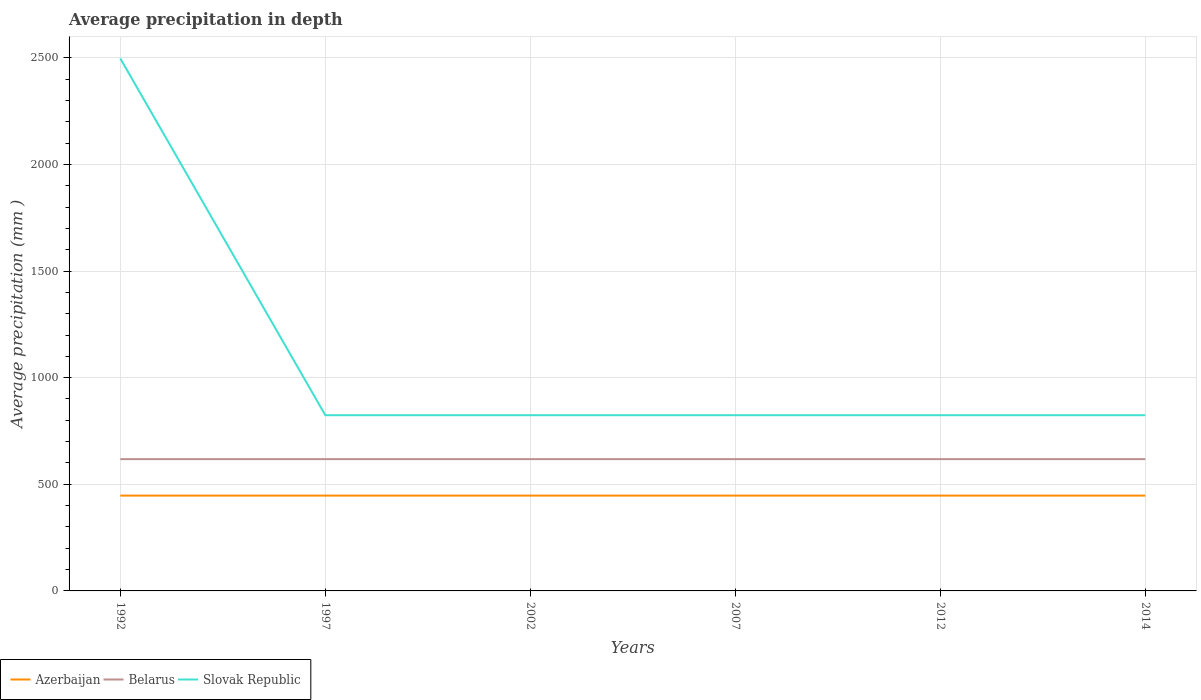Does the line corresponding to Azerbaijan intersect with the line corresponding to Slovak Republic?
Keep it short and to the point. No. Is the number of lines equal to the number of legend labels?
Your answer should be very brief. Yes. Across all years, what is the maximum average precipitation in Azerbaijan?
Ensure brevity in your answer.  447. What is the difference between the highest and the lowest average precipitation in Slovak Republic?
Provide a succinct answer. 1. Is the average precipitation in Slovak Republic strictly greater than the average precipitation in Azerbaijan over the years?
Your response must be concise. No. How many years are there in the graph?
Make the answer very short. 6. Are the values on the major ticks of Y-axis written in scientific E-notation?
Ensure brevity in your answer.  No. What is the title of the graph?
Your response must be concise. Average precipitation in depth. What is the label or title of the Y-axis?
Provide a succinct answer. Average precipitation (mm ). What is the Average precipitation (mm ) in Azerbaijan in 1992?
Make the answer very short. 447. What is the Average precipitation (mm ) in Belarus in 1992?
Ensure brevity in your answer.  618. What is the Average precipitation (mm ) in Slovak Republic in 1992?
Make the answer very short. 2497. What is the Average precipitation (mm ) of Azerbaijan in 1997?
Your answer should be compact. 447. What is the Average precipitation (mm ) of Belarus in 1997?
Ensure brevity in your answer.  618. What is the Average precipitation (mm ) in Slovak Republic in 1997?
Offer a terse response. 824. What is the Average precipitation (mm ) in Azerbaijan in 2002?
Provide a short and direct response. 447. What is the Average precipitation (mm ) in Belarus in 2002?
Offer a very short reply. 618. What is the Average precipitation (mm ) of Slovak Republic in 2002?
Provide a succinct answer. 824. What is the Average precipitation (mm ) of Azerbaijan in 2007?
Provide a short and direct response. 447. What is the Average precipitation (mm ) of Belarus in 2007?
Your answer should be very brief. 618. What is the Average precipitation (mm ) in Slovak Republic in 2007?
Your answer should be very brief. 824. What is the Average precipitation (mm ) in Azerbaijan in 2012?
Make the answer very short. 447. What is the Average precipitation (mm ) of Belarus in 2012?
Ensure brevity in your answer.  618. What is the Average precipitation (mm ) in Slovak Republic in 2012?
Your response must be concise. 824. What is the Average precipitation (mm ) in Azerbaijan in 2014?
Give a very brief answer. 447. What is the Average precipitation (mm ) of Belarus in 2014?
Make the answer very short. 618. What is the Average precipitation (mm ) of Slovak Republic in 2014?
Offer a very short reply. 824. Across all years, what is the maximum Average precipitation (mm ) of Azerbaijan?
Provide a short and direct response. 447. Across all years, what is the maximum Average precipitation (mm ) of Belarus?
Give a very brief answer. 618. Across all years, what is the maximum Average precipitation (mm ) of Slovak Republic?
Your response must be concise. 2497. Across all years, what is the minimum Average precipitation (mm ) in Azerbaijan?
Your answer should be compact. 447. Across all years, what is the minimum Average precipitation (mm ) in Belarus?
Your answer should be compact. 618. Across all years, what is the minimum Average precipitation (mm ) of Slovak Republic?
Your answer should be very brief. 824. What is the total Average precipitation (mm ) of Azerbaijan in the graph?
Make the answer very short. 2682. What is the total Average precipitation (mm ) in Belarus in the graph?
Your answer should be very brief. 3708. What is the total Average precipitation (mm ) of Slovak Republic in the graph?
Keep it short and to the point. 6617. What is the difference between the Average precipitation (mm ) of Azerbaijan in 1992 and that in 1997?
Give a very brief answer. 0. What is the difference between the Average precipitation (mm ) of Slovak Republic in 1992 and that in 1997?
Offer a very short reply. 1673. What is the difference between the Average precipitation (mm ) in Azerbaijan in 1992 and that in 2002?
Offer a terse response. 0. What is the difference between the Average precipitation (mm ) in Slovak Republic in 1992 and that in 2002?
Your answer should be very brief. 1673. What is the difference between the Average precipitation (mm ) of Azerbaijan in 1992 and that in 2007?
Offer a very short reply. 0. What is the difference between the Average precipitation (mm ) of Slovak Republic in 1992 and that in 2007?
Offer a terse response. 1673. What is the difference between the Average precipitation (mm ) of Belarus in 1992 and that in 2012?
Provide a short and direct response. 0. What is the difference between the Average precipitation (mm ) of Slovak Republic in 1992 and that in 2012?
Offer a terse response. 1673. What is the difference between the Average precipitation (mm ) in Azerbaijan in 1992 and that in 2014?
Your answer should be very brief. 0. What is the difference between the Average precipitation (mm ) of Belarus in 1992 and that in 2014?
Your response must be concise. 0. What is the difference between the Average precipitation (mm ) in Slovak Republic in 1992 and that in 2014?
Your response must be concise. 1673. What is the difference between the Average precipitation (mm ) in Belarus in 1997 and that in 2002?
Your answer should be very brief. 0. What is the difference between the Average precipitation (mm ) in Slovak Republic in 1997 and that in 2007?
Provide a short and direct response. 0. What is the difference between the Average precipitation (mm ) in Azerbaijan in 1997 and that in 2012?
Ensure brevity in your answer.  0. What is the difference between the Average precipitation (mm ) in Belarus in 1997 and that in 2012?
Give a very brief answer. 0. What is the difference between the Average precipitation (mm ) in Azerbaijan in 1997 and that in 2014?
Keep it short and to the point. 0. What is the difference between the Average precipitation (mm ) of Belarus in 1997 and that in 2014?
Make the answer very short. 0. What is the difference between the Average precipitation (mm ) of Azerbaijan in 2002 and that in 2007?
Your answer should be very brief. 0. What is the difference between the Average precipitation (mm ) in Belarus in 2002 and that in 2012?
Offer a terse response. 0. What is the difference between the Average precipitation (mm ) in Slovak Republic in 2002 and that in 2012?
Ensure brevity in your answer.  0. What is the difference between the Average precipitation (mm ) of Azerbaijan in 2002 and that in 2014?
Provide a succinct answer. 0. What is the difference between the Average precipitation (mm ) of Slovak Republic in 2002 and that in 2014?
Your answer should be compact. 0. What is the difference between the Average precipitation (mm ) in Slovak Republic in 2007 and that in 2014?
Make the answer very short. 0. What is the difference between the Average precipitation (mm ) in Belarus in 2012 and that in 2014?
Provide a succinct answer. 0. What is the difference between the Average precipitation (mm ) of Azerbaijan in 1992 and the Average precipitation (mm ) of Belarus in 1997?
Make the answer very short. -171. What is the difference between the Average precipitation (mm ) in Azerbaijan in 1992 and the Average precipitation (mm ) in Slovak Republic in 1997?
Offer a very short reply. -377. What is the difference between the Average precipitation (mm ) in Belarus in 1992 and the Average precipitation (mm ) in Slovak Republic in 1997?
Your answer should be very brief. -206. What is the difference between the Average precipitation (mm ) of Azerbaijan in 1992 and the Average precipitation (mm ) of Belarus in 2002?
Make the answer very short. -171. What is the difference between the Average precipitation (mm ) of Azerbaijan in 1992 and the Average precipitation (mm ) of Slovak Republic in 2002?
Provide a short and direct response. -377. What is the difference between the Average precipitation (mm ) of Belarus in 1992 and the Average precipitation (mm ) of Slovak Republic in 2002?
Give a very brief answer. -206. What is the difference between the Average precipitation (mm ) in Azerbaijan in 1992 and the Average precipitation (mm ) in Belarus in 2007?
Make the answer very short. -171. What is the difference between the Average precipitation (mm ) of Azerbaijan in 1992 and the Average precipitation (mm ) of Slovak Republic in 2007?
Provide a short and direct response. -377. What is the difference between the Average precipitation (mm ) in Belarus in 1992 and the Average precipitation (mm ) in Slovak Republic in 2007?
Provide a short and direct response. -206. What is the difference between the Average precipitation (mm ) of Azerbaijan in 1992 and the Average precipitation (mm ) of Belarus in 2012?
Offer a very short reply. -171. What is the difference between the Average precipitation (mm ) of Azerbaijan in 1992 and the Average precipitation (mm ) of Slovak Republic in 2012?
Offer a very short reply. -377. What is the difference between the Average precipitation (mm ) in Belarus in 1992 and the Average precipitation (mm ) in Slovak Republic in 2012?
Your answer should be compact. -206. What is the difference between the Average precipitation (mm ) in Azerbaijan in 1992 and the Average precipitation (mm ) in Belarus in 2014?
Provide a succinct answer. -171. What is the difference between the Average precipitation (mm ) in Azerbaijan in 1992 and the Average precipitation (mm ) in Slovak Republic in 2014?
Provide a succinct answer. -377. What is the difference between the Average precipitation (mm ) in Belarus in 1992 and the Average precipitation (mm ) in Slovak Republic in 2014?
Keep it short and to the point. -206. What is the difference between the Average precipitation (mm ) of Azerbaijan in 1997 and the Average precipitation (mm ) of Belarus in 2002?
Give a very brief answer. -171. What is the difference between the Average precipitation (mm ) in Azerbaijan in 1997 and the Average precipitation (mm ) in Slovak Republic in 2002?
Provide a succinct answer. -377. What is the difference between the Average precipitation (mm ) in Belarus in 1997 and the Average precipitation (mm ) in Slovak Republic in 2002?
Provide a short and direct response. -206. What is the difference between the Average precipitation (mm ) in Azerbaijan in 1997 and the Average precipitation (mm ) in Belarus in 2007?
Offer a very short reply. -171. What is the difference between the Average precipitation (mm ) of Azerbaijan in 1997 and the Average precipitation (mm ) of Slovak Republic in 2007?
Give a very brief answer. -377. What is the difference between the Average precipitation (mm ) of Belarus in 1997 and the Average precipitation (mm ) of Slovak Republic in 2007?
Your answer should be compact. -206. What is the difference between the Average precipitation (mm ) of Azerbaijan in 1997 and the Average precipitation (mm ) of Belarus in 2012?
Your answer should be compact. -171. What is the difference between the Average precipitation (mm ) in Azerbaijan in 1997 and the Average precipitation (mm ) in Slovak Republic in 2012?
Keep it short and to the point. -377. What is the difference between the Average precipitation (mm ) of Belarus in 1997 and the Average precipitation (mm ) of Slovak Republic in 2012?
Ensure brevity in your answer.  -206. What is the difference between the Average precipitation (mm ) of Azerbaijan in 1997 and the Average precipitation (mm ) of Belarus in 2014?
Ensure brevity in your answer.  -171. What is the difference between the Average precipitation (mm ) in Azerbaijan in 1997 and the Average precipitation (mm ) in Slovak Republic in 2014?
Your response must be concise. -377. What is the difference between the Average precipitation (mm ) of Belarus in 1997 and the Average precipitation (mm ) of Slovak Republic in 2014?
Your answer should be very brief. -206. What is the difference between the Average precipitation (mm ) of Azerbaijan in 2002 and the Average precipitation (mm ) of Belarus in 2007?
Provide a succinct answer. -171. What is the difference between the Average precipitation (mm ) in Azerbaijan in 2002 and the Average precipitation (mm ) in Slovak Republic in 2007?
Make the answer very short. -377. What is the difference between the Average precipitation (mm ) in Belarus in 2002 and the Average precipitation (mm ) in Slovak Republic in 2007?
Your answer should be compact. -206. What is the difference between the Average precipitation (mm ) of Azerbaijan in 2002 and the Average precipitation (mm ) of Belarus in 2012?
Ensure brevity in your answer.  -171. What is the difference between the Average precipitation (mm ) in Azerbaijan in 2002 and the Average precipitation (mm ) in Slovak Republic in 2012?
Provide a short and direct response. -377. What is the difference between the Average precipitation (mm ) of Belarus in 2002 and the Average precipitation (mm ) of Slovak Republic in 2012?
Offer a terse response. -206. What is the difference between the Average precipitation (mm ) in Azerbaijan in 2002 and the Average precipitation (mm ) in Belarus in 2014?
Provide a short and direct response. -171. What is the difference between the Average precipitation (mm ) of Azerbaijan in 2002 and the Average precipitation (mm ) of Slovak Republic in 2014?
Make the answer very short. -377. What is the difference between the Average precipitation (mm ) in Belarus in 2002 and the Average precipitation (mm ) in Slovak Republic in 2014?
Your response must be concise. -206. What is the difference between the Average precipitation (mm ) in Azerbaijan in 2007 and the Average precipitation (mm ) in Belarus in 2012?
Make the answer very short. -171. What is the difference between the Average precipitation (mm ) of Azerbaijan in 2007 and the Average precipitation (mm ) of Slovak Republic in 2012?
Make the answer very short. -377. What is the difference between the Average precipitation (mm ) of Belarus in 2007 and the Average precipitation (mm ) of Slovak Republic in 2012?
Provide a succinct answer. -206. What is the difference between the Average precipitation (mm ) of Azerbaijan in 2007 and the Average precipitation (mm ) of Belarus in 2014?
Your answer should be very brief. -171. What is the difference between the Average precipitation (mm ) of Azerbaijan in 2007 and the Average precipitation (mm ) of Slovak Republic in 2014?
Provide a succinct answer. -377. What is the difference between the Average precipitation (mm ) in Belarus in 2007 and the Average precipitation (mm ) in Slovak Republic in 2014?
Keep it short and to the point. -206. What is the difference between the Average precipitation (mm ) in Azerbaijan in 2012 and the Average precipitation (mm ) in Belarus in 2014?
Keep it short and to the point. -171. What is the difference between the Average precipitation (mm ) of Azerbaijan in 2012 and the Average precipitation (mm ) of Slovak Republic in 2014?
Your answer should be very brief. -377. What is the difference between the Average precipitation (mm ) of Belarus in 2012 and the Average precipitation (mm ) of Slovak Republic in 2014?
Offer a very short reply. -206. What is the average Average precipitation (mm ) of Azerbaijan per year?
Ensure brevity in your answer.  447. What is the average Average precipitation (mm ) in Belarus per year?
Give a very brief answer. 618. What is the average Average precipitation (mm ) in Slovak Republic per year?
Give a very brief answer. 1102.83. In the year 1992, what is the difference between the Average precipitation (mm ) of Azerbaijan and Average precipitation (mm ) of Belarus?
Keep it short and to the point. -171. In the year 1992, what is the difference between the Average precipitation (mm ) in Azerbaijan and Average precipitation (mm ) in Slovak Republic?
Make the answer very short. -2050. In the year 1992, what is the difference between the Average precipitation (mm ) of Belarus and Average precipitation (mm ) of Slovak Republic?
Your answer should be compact. -1879. In the year 1997, what is the difference between the Average precipitation (mm ) of Azerbaijan and Average precipitation (mm ) of Belarus?
Provide a short and direct response. -171. In the year 1997, what is the difference between the Average precipitation (mm ) in Azerbaijan and Average precipitation (mm ) in Slovak Republic?
Give a very brief answer. -377. In the year 1997, what is the difference between the Average precipitation (mm ) of Belarus and Average precipitation (mm ) of Slovak Republic?
Provide a short and direct response. -206. In the year 2002, what is the difference between the Average precipitation (mm ) of Azerbaijan and Average precipitation (mm ) of Belarus?
Your answer should be compact. -171. In the year 2002, what is the difference between the Average precipitation (mm ) in Azerbaijan and Average precipitation (mm ) in Slovak Republic?
Your answer should be compact. -377. In the year 2002, what is the difference between the Average precipitation (mm ) of Belarus and Average precipitation (mm ) of Slovak Republic?
Keep it short and to the point. -206. In the year 2007, what is the difference between the Average precipitation (mm ) in Azerbaijan and Average precipitation (mm ) in Belarus?
Give a very brief answer. -171. In the year 2007, what is the difference between the Average precipitation (mm ) of Azerbaijan and Average precipitation (mm ) of Slovak Republic?
Provide a short and direct response. -377. In the year 2007, what is the difference between the Average precipitation (mm ) of Belarus and Average precipitation (mm ) of Slovak Republic?
Provide a short and direct response. -206. In the year 2012, what is the difference between the Average precipitation (mm ) in Azerbaijan and Average precipitation (mm ) in Belarus?
Your answer should be very brief. -171. In the year 2012, what is the difference between the Average precipitation (mm ) of Azerbaijan and Average precipitation (mm ) of Slovak Republic?
Make the answer very short. -377. In the year 2012, what is the difference between the Average precipitation (mm ) of Belarus and Average precipitation (mm ) of Slovak Republic?
Your answer should be compact. -206. In the year 2014, what is the difference between the Average precipitation (mm ) in Azerbaijan and Average precipitation (mm ) in Belarus?
Your response must be concise. -171. In the year 2014, what is the difference between the Average precipitation (mm ) of Azerbaijan and Average precipitation (mm ) of Slovak Republic?
Provide a succinct answer. -377. In the year 2014, what is the difference between the Average precipitation (mm ) in Belarus and Average precipitation (mm ) in Slovak Republic?
Provide a short and direct response. -206. What is the ratio of the Average precipitation (mm ) in Azerbaijan in 1992 to that in 1997?
Ensure brevity in your answer.  1. What is the ratio of the Average precipitation (mm ) in Slovak Republic in 1992 to that in 1997?
Provide a succinct answer. 3.03. What is the ratio of the Average precipitation (mm ) of Azerbaijan in 1992 to that in 2002?
Your answer should be compact. 1. What is the ratio of the Average precipitation (mm ) of Slovak Republic in 1992 to that in 2002?
Your answer should be compact. 3.03. What is the ratio of the Average precipitation (mm ) in Slovak Republic in 1992 to that in 2007?
Ensure brevity in your answer.  3.03. What is the ratio of the Average precipitation (mm ) in Belarus in 1992 to that in 2012?
Provide a succinct answer. 1. What is the ratio of the Average precipitation (mm ) in Slovak Republic in 1992 to that in 2012?
Provide a short and direct response. 3.03. What is the ratio of the Average precipitation (mm ) of Azerbaijan in 1992 to that in 2014?
Your response must be concise. 1. What is the ratio of the Average precipitation (mm ) in Belarus in 1992 to that in 2014?
Your answer should be very brief. 1. What is the ratio of the Average precipitation (mm ) in Slovak Republic in 1992 to that in 2014?
Ensure brevity in your answer.  3.03. What is the ratio of the Average precipitation (mm ) of Slovak Republic in 1997 to that in 2002?
Keep it short and to the point. 1. What is the ratio of the Average precipitation (mm ) in Belarus in 1997 to that in 2012?
Provide a succinct answer. 1. What is the ratio of the Average precipitation (mm ) in Azerbaijan in 1997 to that in 2014?
Give a very brief answer. 1. What is the ratio of the Average precipitation (mm ) in Belarus in 1997 to that in 2014?
Keep it short and to the point. 1. What is the ratio of the Average precipitation (mm ) of Belarus in 2002 to that in 2007?
Provide a succinct answer. 1. What is the ratio of the Average precipitation (mm ) of Belarus in 2002 to that in 2012?
Your answer should be very brief. 1. What is the ratio of the Average precipitation (mm ) in Slovak Republic in 2002 to that in 2012?
Offer a terse response. 1. What is the ratio of the Average precipitation (mm ) in Belarus in 2002 to that in 2014?
Provide a succinct answer. 1. What is the ratio of the Average precipitation (mm ) of Slovak Republic in 2002 to that in 2014?
Your answer should be compact. 1. What is the ratio of the Average precipitation (mm ) in Azerbaijan in 2007 to that in 2012?
Offer a terse response. 1. What is the ratio of the Average precipitation (mm ) of Belarus in 2007 to that in 2012?
Keep it short and to the point. 1. What is the ratio of the Average precipitation (mm ) of Slovak Republic in 2007 to that in 2014?
Provide a succinct answer. 1. What is the ratio of the Average precipitation (mm ) in Belarus in 2012 to that in 2014?
Your answer should be very brief. 1. What is the ratio of the Average precipitation (mm ) in Slovak Republic in 2012 to that in 2014?
Your response must be concise. 1. What is the difference between the highest and the second highest Average precipitation (mm ) of Azerbaijan?
Offer a very short reply. 0. What is the difference between the highest and the second highest Average precipitation (mm ) in Slovak Republic?
Make the answer very short. 1673. What is the difference between the highest and the lowest Average precipitation (mm ) in Azerbaijan?
Offer a terse response. 0. What is the difference between the highest and the lowest Average precipitation (mm ) of Belarus?
Ensure brevity in your answer.  0. What is the difference between the highest and the lowest Average precipitation (mm ) of Slovak Republic?
Your answer should be very brief. 1673. 